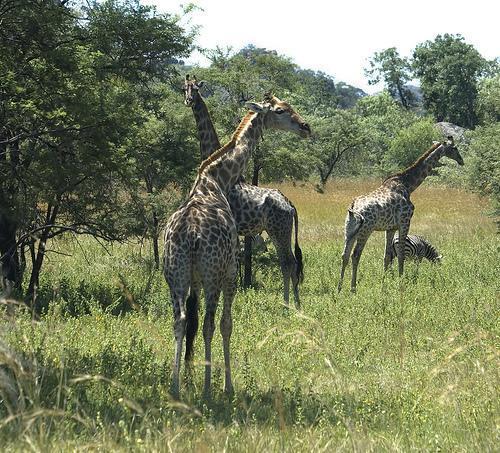How many zebras can be seen?
Give a very brief answer. 1. 